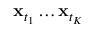<formula> <loc_0><loc_0><loc_500><loc_500>x _ { t _ { 1 } } \dots x _ { t _ { K } }</formula> 